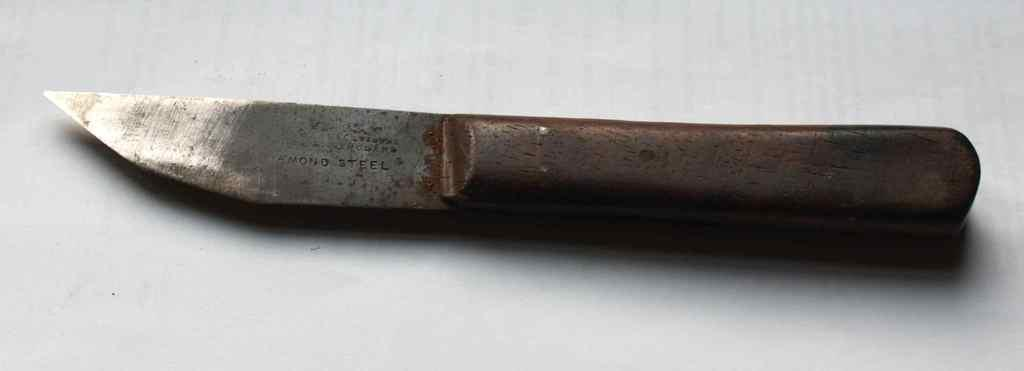What object can be seen in the picture? There is a knife in the picture. What is the color of the knife's handle? The handle of the knife is brown. What is the blade of the knife like? The knife has a sharp edged blade. What color is the background of the image? The background of the image is white. How many glasses can be seen in the image? There are no glasses present in the image; it only features a knife. What type of bomb is depicted in the image? There is no bomb present in the image; it only features a knife. 